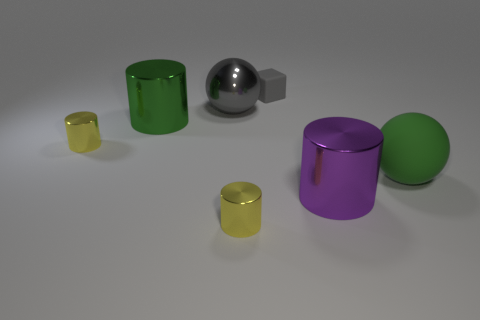There is a big metallic thing that is the same color as the small cube; what is its shape?
Make the answer very short. Sphere. What color is the large sphere that is made of the same material as the purple cylinder?
Offer a terse response. Gray. What number of things are large red cubes or large gray shiny objects?
Your answer should be compact. 1. Do the gray shiny ball and the gray rubber block that is behind the green rubber thing have the same size?
Offer a terse response. No. What is the color of the large cylinder that is on the right side of the yellow shiny cylinder that is to the right of the big metallic cylinder to the left of the small matte thing?
Ensure brevity in your answer.  Purple. What is the color of the big rubber ball?
Your response must be concise. Green. Is the number of big metallic things that are left of the small gray cube greater than the number of big green rubber things that are left of the gray metal sphere?
Provide a succinct answer. Yes. There is a big green rubber object; is its shape the same as the metallic thing that is behind the large green metal object?
Offer a very short reply. Yes. Does the yellow thing behind the big purple object have the same size as the thing in front of the purple metal cylinder?
Your answer should be very brief. Yes. There is a tiny gray matte cube behind the big sphere left of the big green matte thing; are there any gray things that are in front of it?
Give a very brief answer. Yes. 